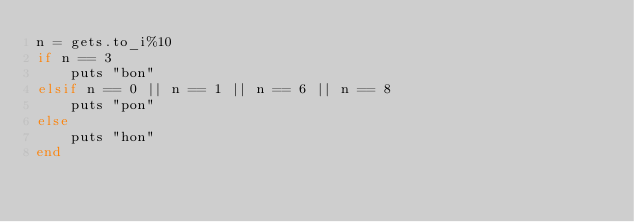Convert code to text. <code><loc_0><loc_0><loc_500><loc_500><_Ruby_>n = gets.to_i%10
if n == 3
    puts "bon"
elsif n == 0 || n == 1 || n == 6 || n == 8
    puts "pon"
else 
    puts "hon"
end</code> 